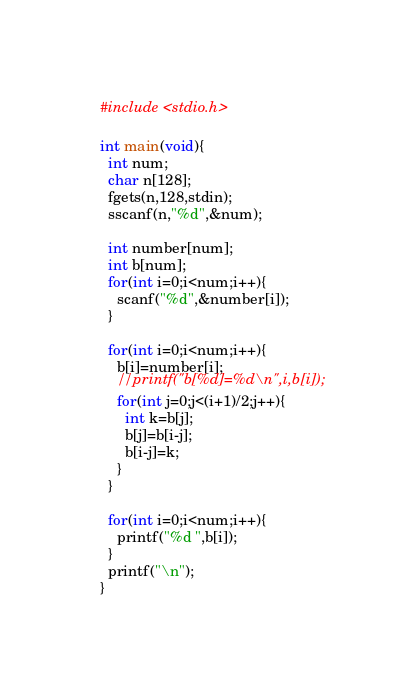<code> <loc_0><loc_0><loc_500><loc_500><_C_>#include <stdio.h>

int main(void){
  int num;
  char n[128];
  fgets(n,128,stdin);
  sscanf(n,"%d",&num);
  
  int number[num];
  int b[num];
  for(int i=0;i<num;i++){
    scanf("%d",&number[i]);
  }

  for(int i=0;i<num;i++){
    b[i]=number[i];
    //printf("b[%d]=%d\n",i,b[i]);
    for(int j=0;j<(i+1)/2;j++){
      int k=b[j];
      b[j]=b[i-j];
      b[i-j]=k;
    }
  }
  
  for(int i=0;i<num;i++){
    printf("%d ",b[i]);
  }
  printf("\n");
}</code> 